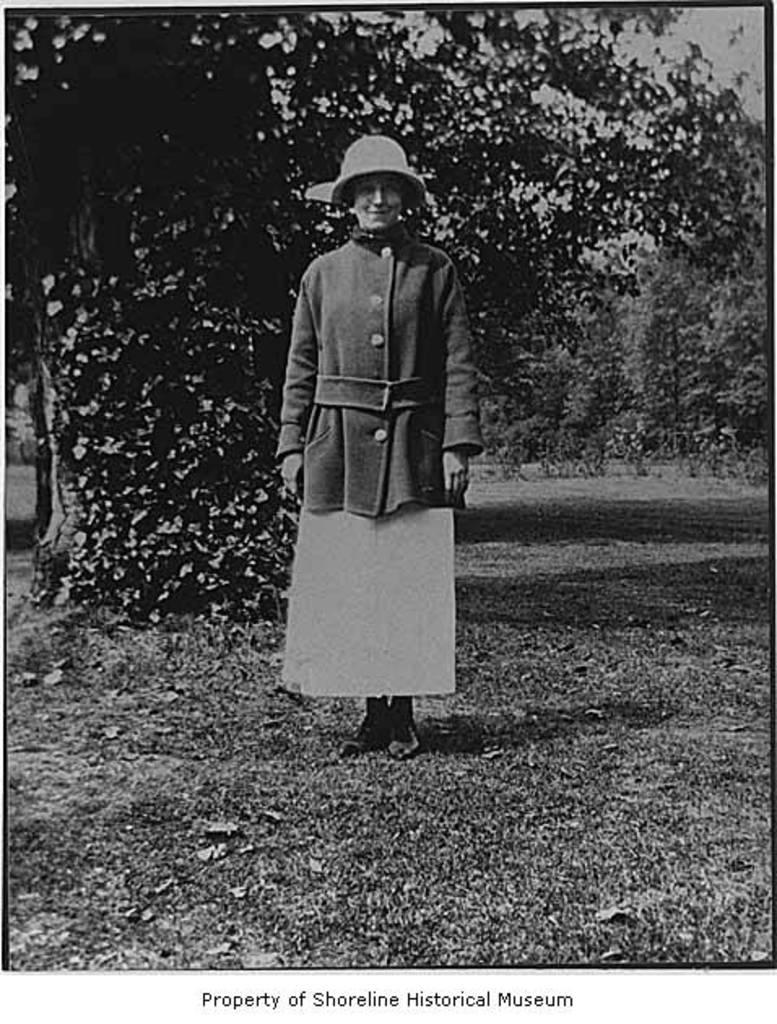What is the color scheme of the image? The photo is black and white. Can you describe the person in the image? There is a person standing in the image, and they are smiling. What can be seen in the background of the image? There are trees in the background of the image. Is there any text present in the image? Yes, there is text at the bottom of the image. What type of marble is the person holding in the image? There is no marble present in the image; it is a black and white photo with a person standing and smiling. What punishment is the person receiving for not completing their homework in the image? There is no indication of homework or punishment in the image; it only shows a person standing and smiling. 